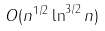Convert formula to latex. <formula><loc_0><loc_0><loc_500><loc_500>O ( n ^ { 1 / 2 } \ln ^ { 3 / 2 } n )</formula> 